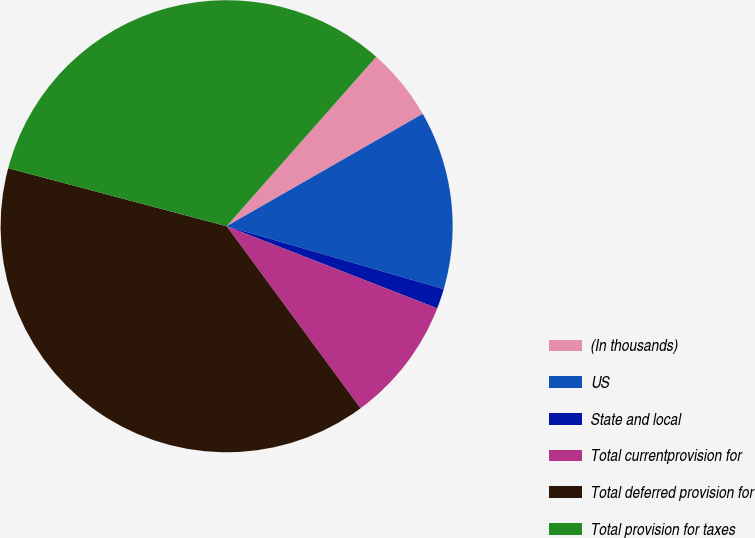<chart> <loc_0><loc_0><loc_500><loc_500><pie_chart><fcel>(In thousands)<fcel>US<fcel>State and local<fcel>Total currentprovision for<fcel>Total deferred provision for<fcel>Total provision for taxes<nl><fcel>5.21%<fcel>12.77%<fcel>1.43%<fcel>8.99%<fcel>39.23%<fcel>32.38%<nl></chart> 